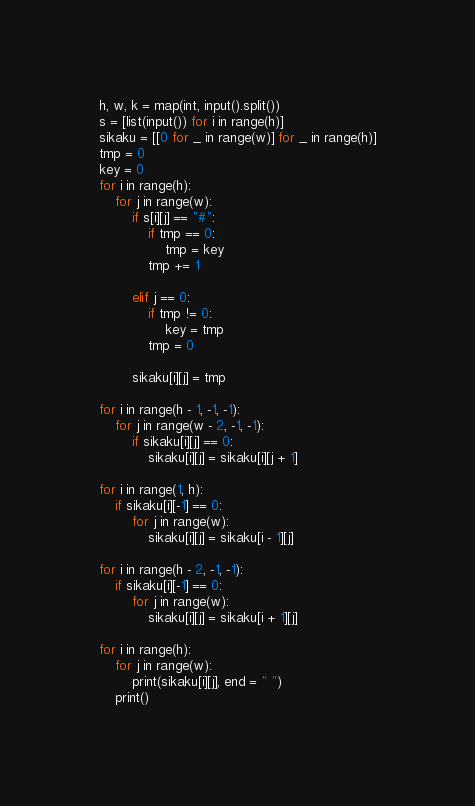<code> <loc_0><loc_0><loc_500><loc_500><_Python_>h, w, k = map(int, input().split())
s = [list(input()) for i in range(h)]
sikaku = [[0 for _ in range(w)] for _ in range(h)]
tmp = 0
key = 0
for i in range(h):
    for j in range(w):
        if s[i][j] == "#":
            if tmp == 0:
                tmp = key
            tmp += 1

        elif j == 0:
            if tmp != 0:
                key = tmp
            tmp = 0

        sikaku[i][j] = tmp

for i in range(h - 1, -1, -1):
    for j in range(w - 2, -1, -1):
        if sikaku[i][j] == 0:
            sikaku[i][j] = sikaku[i][j + 1]

for i in range(1, h):
    if sikaku[i][-1] == 0:
        for j in range(w):
            sikaku[i][j] = sikaku[i - 1][j]

for i in range(h - 2, -1, -1):
    if sikaku[i][-1] == 0:
        for j in range(w):
            sikaku[i][j] = sikaku[i + 1][j]

for i in range(h):
    for j in range(w):
        print(sikaku[i][j], end = " ")
    print()</code> 